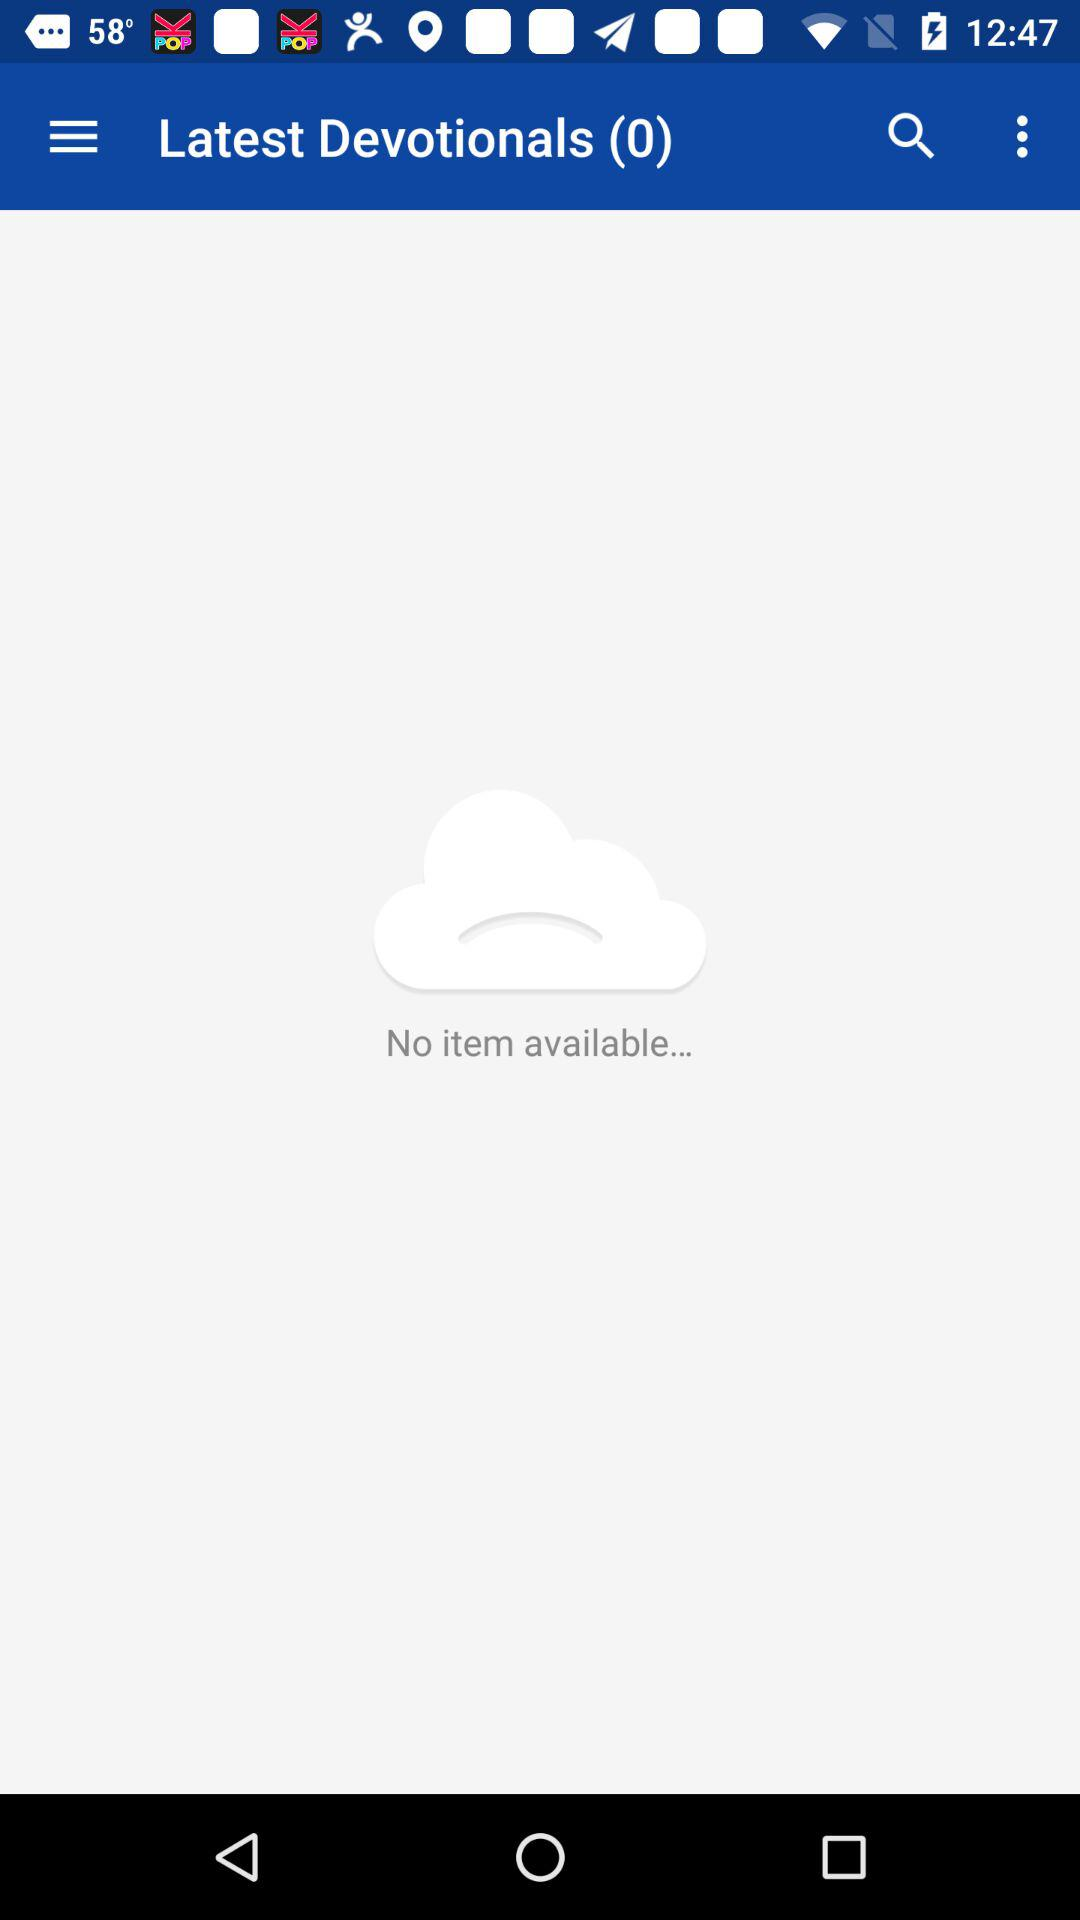What is the count of the latest devotionals? The count is 0. 